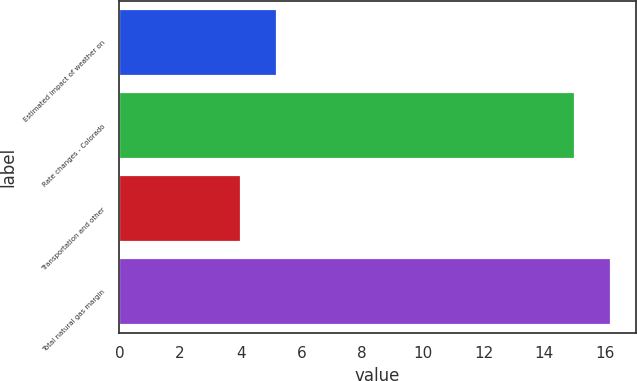Convert chart to OTSL. <chart><loc_0><loc_0><loc_500><loc_500><bar_chart><fcel>Estimated impact of weather on<fcel>Rate changes - Colorado<fcel>Transportation and other<fcel>Total natural gas margin<nl><fcel>5.2<fcel>15<fcel>4<fcel>16.2<nl></chart> 